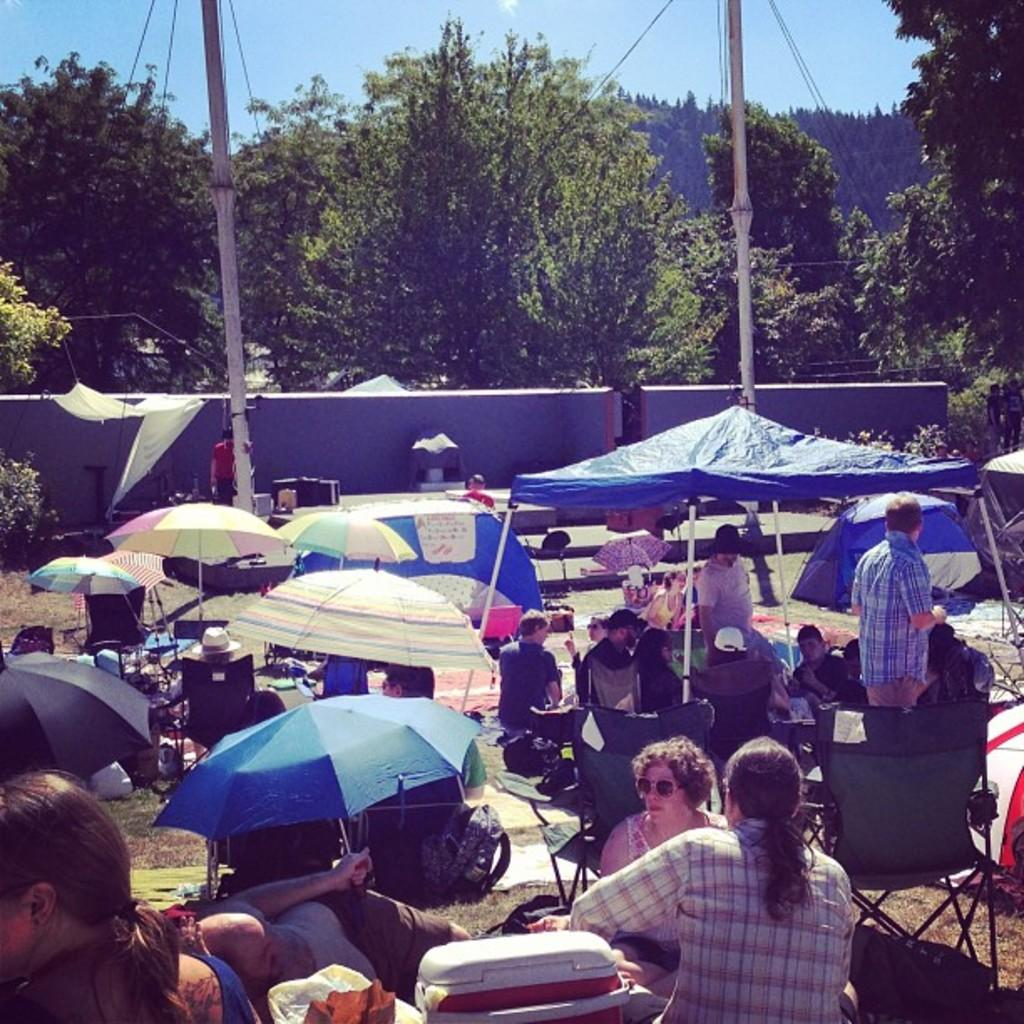What are the persons in the image doing? The persons in the image are on the ground, possibly sitting or standing. What are the umbrellas used for in the image? The umbrellas are used to provide shade for some of the persons in the image. What can be seen in the background of the image? There are two white color poles and trees in the background. What is the color of the sky in the image? The sky is blue in the image. How many legs can be seen on the face of the person in the image? There are no faces with legs visible in the image; it only shows persons with their bodies and umbrellas. 